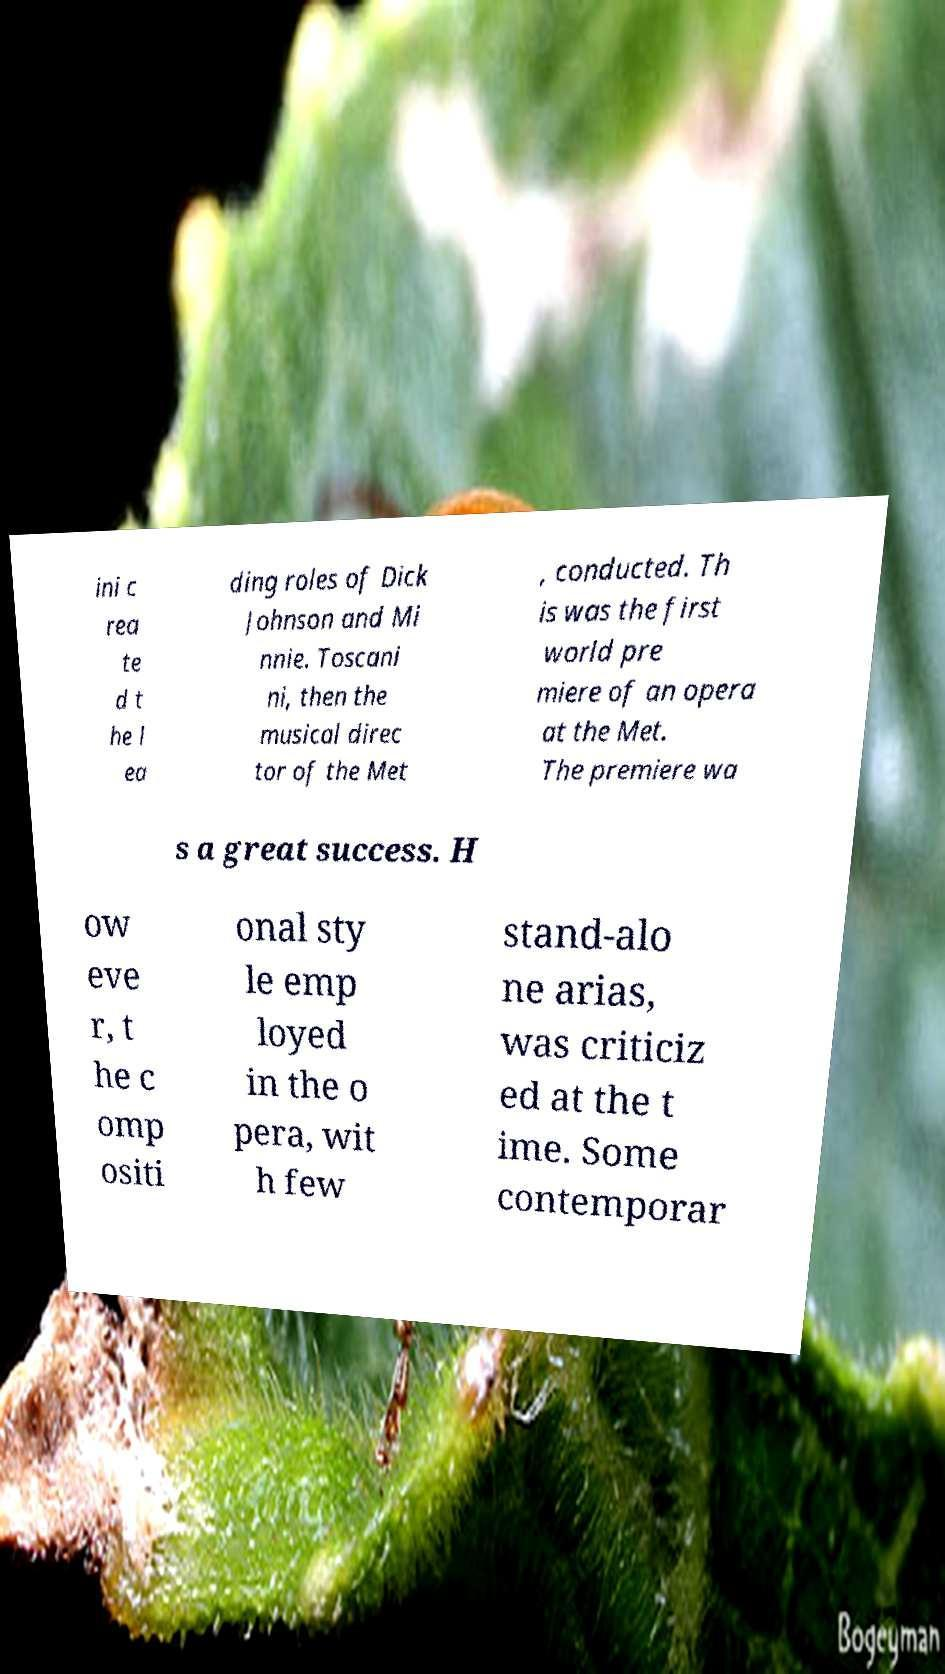There's text embedded in this image that I need extracted. Can you transcribe it verbatim? ini c rea te d t he l ea ding roles of Dick Johnson and Mi nnie. Toscani ni, then the musical direc tor of the Met , conducted. Th is was the first world pre miere of an opera at the Met. The premiere wa s a great success. H ow eve r, t he c omp ositi onal sty le emp loyed in the o pera, wit h few stand-alo ne arias, was criticiz ed at the t ime. Some contemporar 